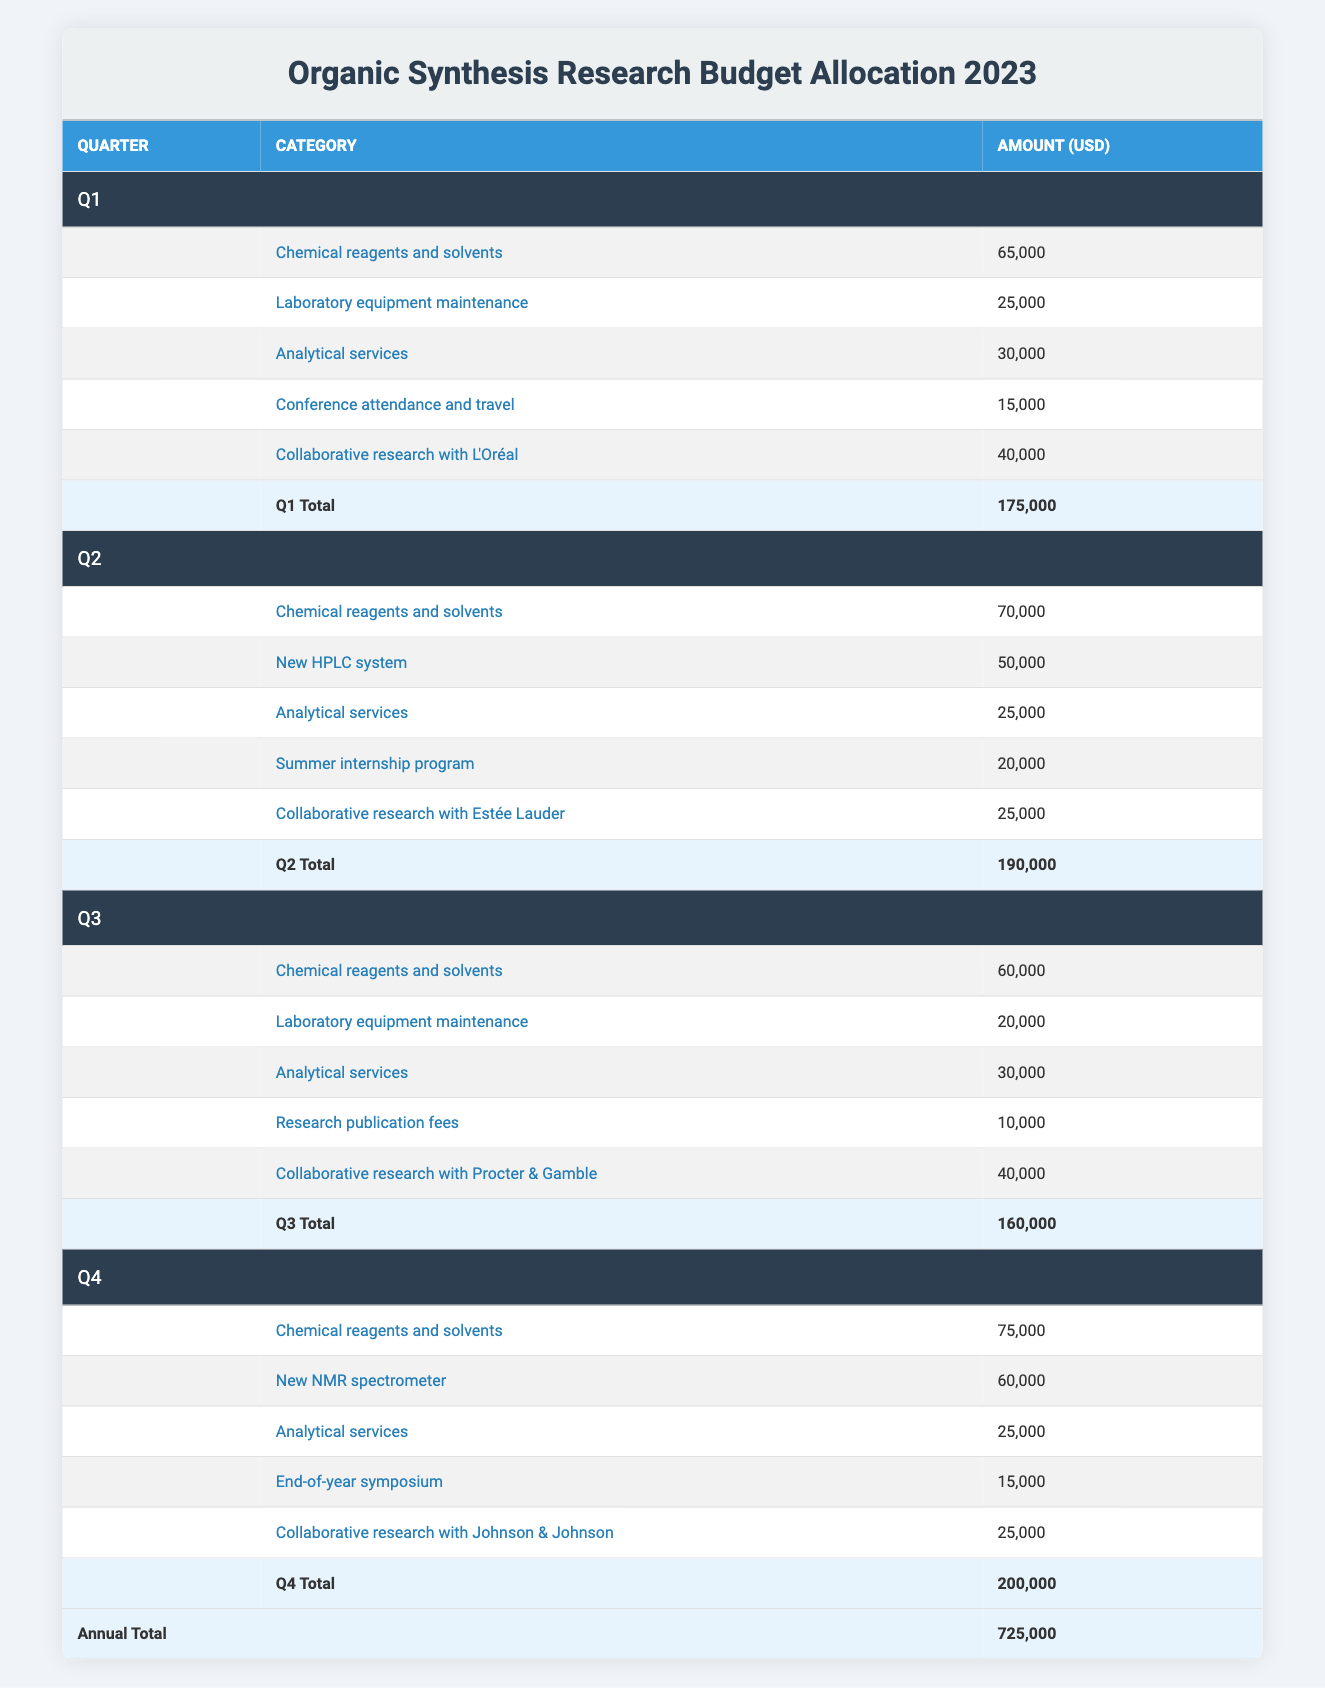What was the total budget allocated for Q2 in 2023? The total budget for Q2 is listed directly in the table. Under the Q2 section, it shows “Q2 Total” with the amount of 190,000 USD specified.
Answer: 190,000 USD What is the budget allocation for 'Analytical services' in Q4? In the Q4 section of the table, the specific entry for 'Analytical services' shows the amount of 25,000 USD allocated for that category.
Answer: 25,000 USD Which quarter had the highest budget allocation? By comparing the total budget amounts across the quarters, I see Q4 has a total budget of 200,000, which is higher than Q1 (175,000), Q2 (190,000), and Q3 (160,000).
Answer: Q4 What is the total amount allocated for 'Chemical reagents and solvents' across all quarters? I sum the allocations for 'Chemical reagents and solvents' across all quarters: Q1 = 65,000 + Q2 = 70,000 + Q3 = 60,000 + Q4 = 75,000. This totals 270,000 USD.
Answer: 270,000 USD Is the budget for the 'New HPLC system' greater than the budget for 'Research publication fees'? I compare the amounts allocated for both categories: The 'New HPLC system' in Q2 is 50,000 USD and 'Research publication fees' in Q3 is 10,000 USD. Since 50,000 is greater than 10,000, the answer is yes.
Answer: Yes How much budget was allocated in Q3 for 'Collaborative research with Procter & Gamble'? Referring to the Q3 section of the table, the amount for 'Collaborative research with Procter & Gamble' is directly stated as 40,000 USD.
Answer: 40,000 USD What percentage of the total 2023 budget is allocated to 'Conference attendance and travel'? First, find the total budget for the year, which is 725,000 USD. The allocation for 'Conference attendance and travel' in Q1 is 15,000 USD. To find the percentage, I calculate (15,000 / 725,000) * 100, which results in about 2.07%.
Answer: 2.07% What is the total budget allocated for 'Collaborative research' with all partners in Q1, Q2, Q3, and Q4? I find the amounts allocated for 'Collaborative research ' in each quarter: Q1 = 40,000 (L'Oréal), Q2 = 25,000 (Estée Lauder), Q3 = 40,000 (Procter & Gamble), and Q4 = 25,000 (Johnson & Johnson). Adding these gives a total of 130,000 USD.
Answer: 130,000 USD Is the total budget allocation for Q1 and Q2 combined greater than that for Q3 and Q4 combined? Calculate the total for Q1 and Q2: Q1 (175,000) + Q2 (190,000) = 365,000. Now calculate the total for Q3 and Q4: Q3 (160,000) + Q4 (200,000) = 360,000. Since 365,000 is greater than 360,000, the answer is yes.
Answer: Yes 